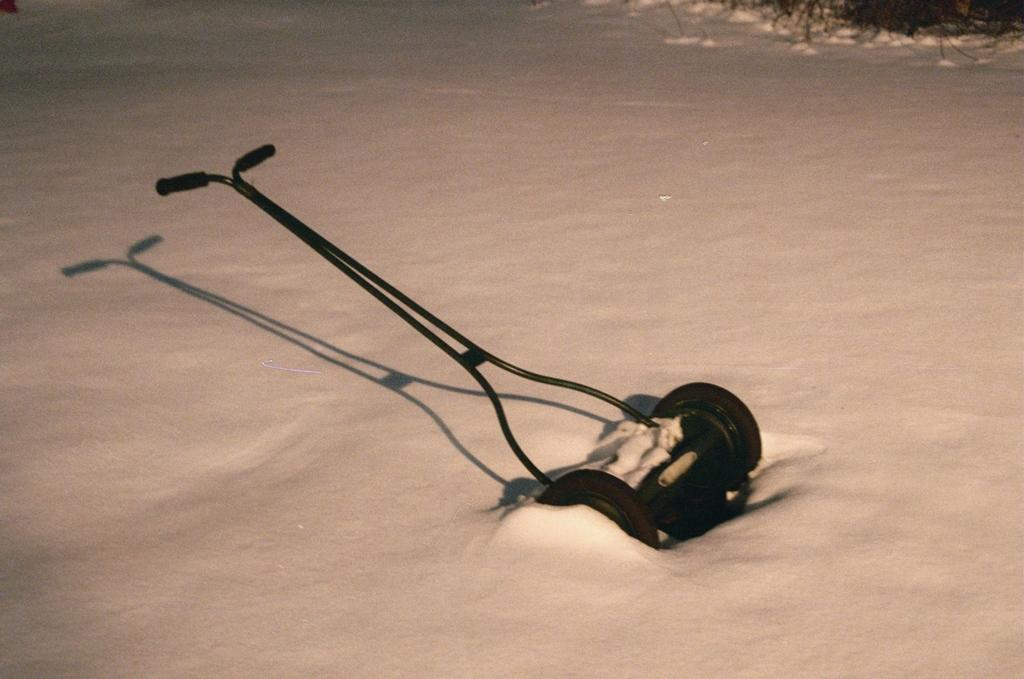What object can be seen in the image? There is a lawn mower in the image. Where is the lawn mower located? The lawn mower is placed on the ground. What type of note is being played by the lawn mower in the image? There is no note being played by the lawn mower in the image, as it is an inanimate object and cannot produce sound. 